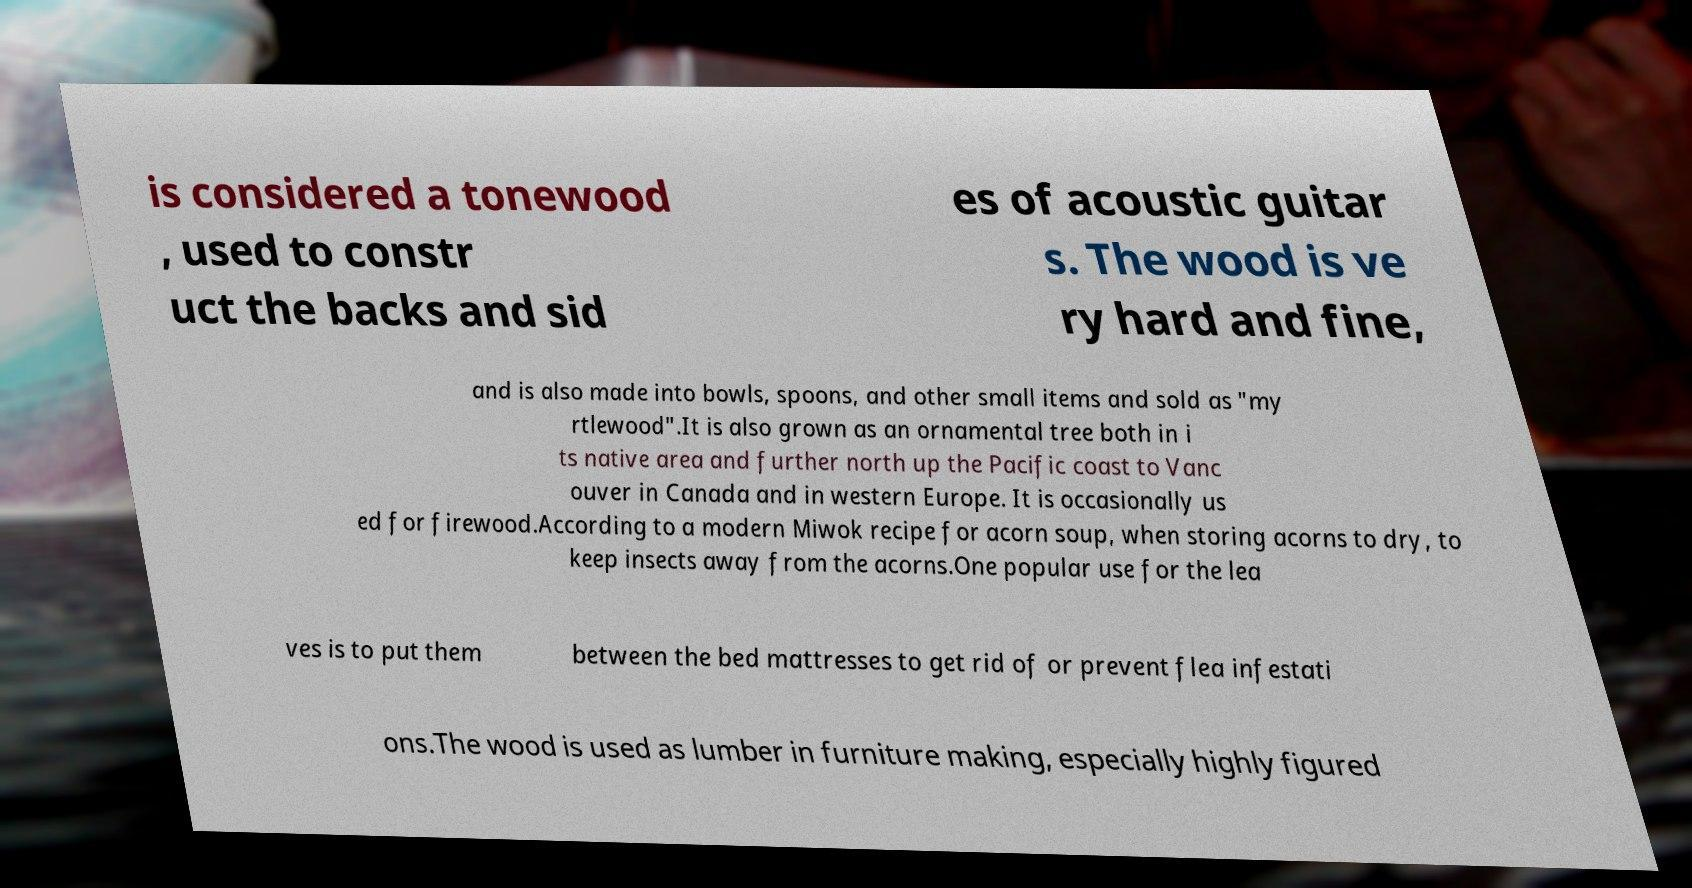What messages or text are displayed in this image? I need them in a readable, typed format. is considered a tonewood , used to constr uct the backs and sid es of acoustic guitar s. The wood is ve ry hard and fine, and is also made into bowls, spoons, and other small items and sold as "my rtlewood".It is also grown as an ornamental tree both in i ts native area and further north up the Pacific coast to Vanc ouver in Canada and in western Europe. It is occasionally us ed for firewood.According to a modern Miwok recipe for acorn soup, when storing acorns to dry, to keep insects away from the acorns.One popular use for the lea ves is to put them between the bed mattresses to get rid of or prevent flea infestati ons.The wood is used as lumber in furniture making, especially highly figured 